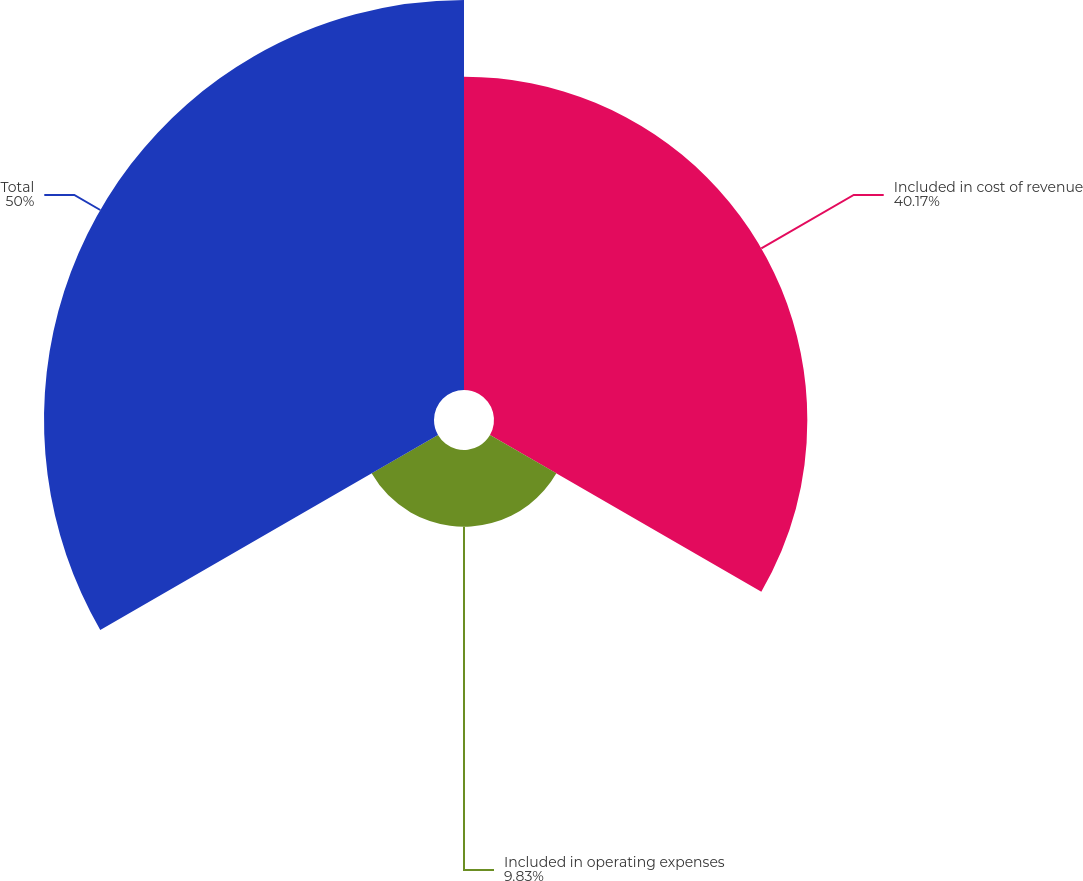<chart> <loc_0><loc_0><loc_500><loc_500><pie_chart><fcel>Included in cost of revenue<fcel>Included in operating expenses<fcel>Total<nl><fcel>40.17%<fcel>9.83%<fcel>50.0%<nl></chart> 